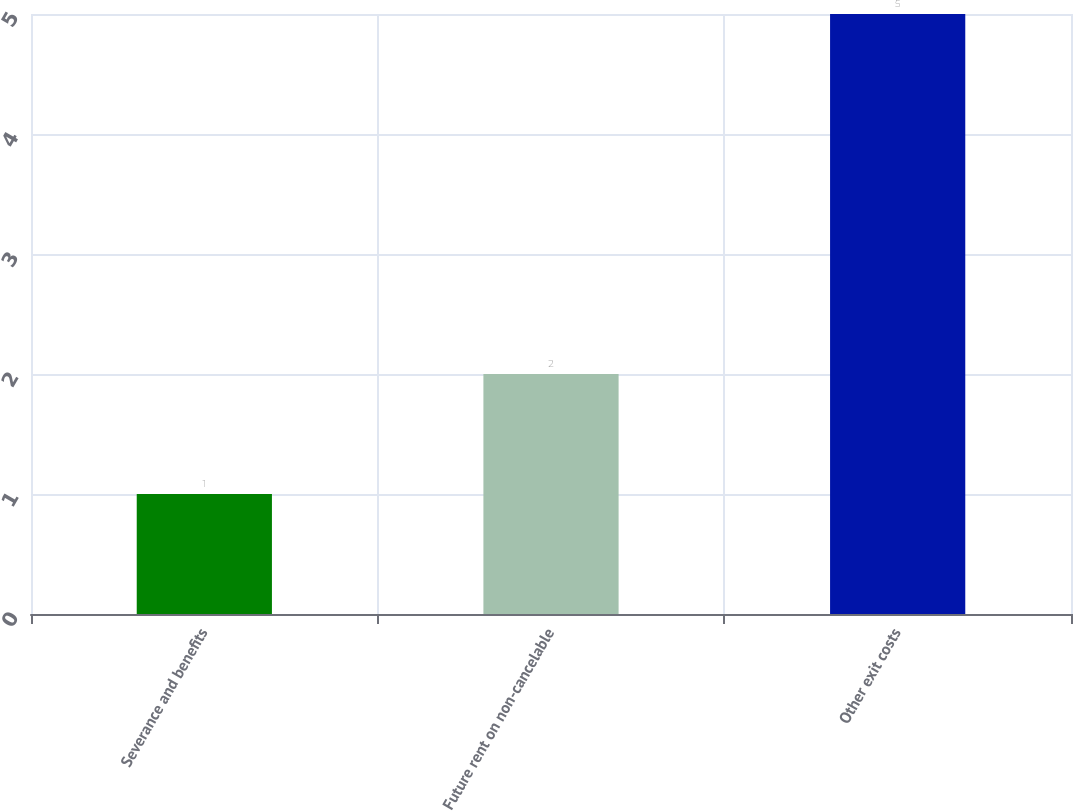<chart> <loc_0><loc_0><loc_500><loc_500><bar_chart><fcel>Severance and benefits<fcel>Future rent on non-cancelable<fcel>Other exit costs<nl><fcel>1<fcel>2<fcel>5<nl></chart> 